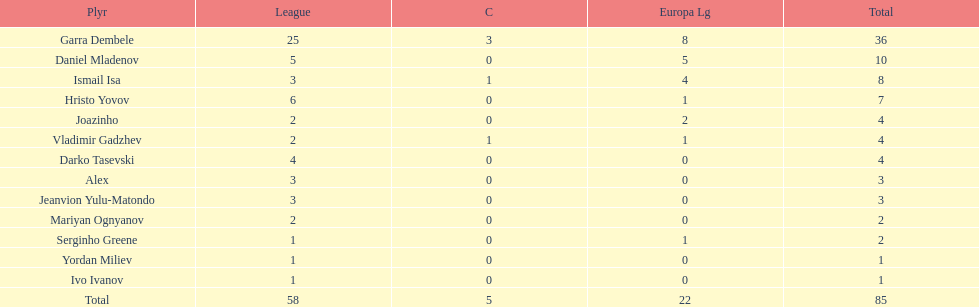How many players did not score a goal in cup play? 10. 